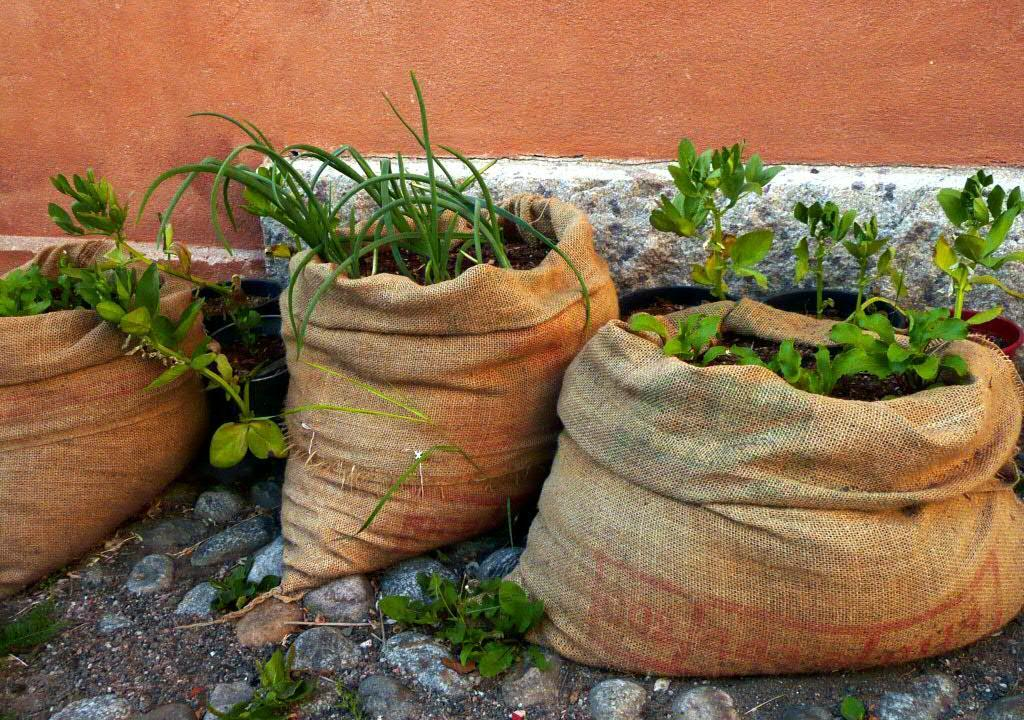What objects are present in the image that contain plants and soil? There are sacks in the image that contain plants and soil. What other objects can be seen in the image? There are stones visible in the image. What is visible in the background of the image? There is a wall in the background of the image. What flavor of toothpaste is used by the person in the image? There is no person present in the image, and therefore no toothpaste or its flavor can be observed. 